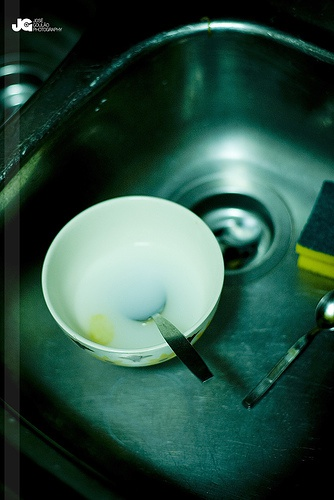Describe the objects in this image and their specific colors. I can see sink in black, teal, beige, and darkgreen tones, bowl in black, beige, lightblue, aquamarine, and turquoise tones, spoon in black, teal, darkgreen, and green tones, and spoon in black, turquoise, and teal tones in this image. 